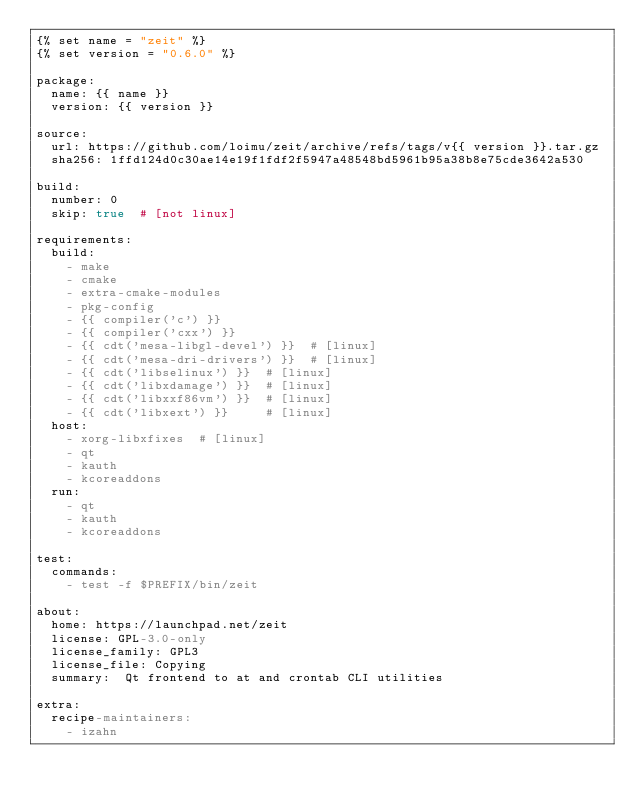<code> <loc_0><loc_0><loc_500><loc_500><_YAML_>{% set name = "zeit" %}
{% set version = "0.6.0" %}

package:
  name: {{ name }}
  version: {{ version }}

source:
  url: https://github.com/loimu/zeit/archive/refs/tags/v{{ version }}.tar.gz
  sha256: 1ffd124d0c30ae14e19f1fdf2f5947a48548bd5961b95a38b8e75cde3642a530

build:
  number: 0
  skip: true  # [not linux]

requirements:
  build:
    - make
    - cmake
    - extra-cmake-modules
    - pkg-config
    - {{ compiler('c') }}
    - {{ compiler('cxx') }}
    - {{ cdt('mesa-libgl-devel') }}  # [linux]
    - {{ cdt('mesa-dri-drivers') }}  # [linux]
    - {{ cdt('libselinux') }}  # [linux]
    - {{ cdt('libxdamage') }}  # [linux]
    - {{ cdt('libxxf86vm') }}  # [linux]
    - {{ cdt('libxext') }}     # [linux]
  host:
    - xorg-libxfixes  # [linux]
    - qt
    - kauth
    - kcoreaddons
  run:
    - qt
    - kauth
    - kcoreaddons

test:
  commands:
    - test -f $PREFIX/bin/zeit

about:
  home: https://launchpad.net/zeit
  license: GPL-3.0-only
  license_family: GPL3
  license_file: Copying
  summary:  Qt frontend to at and crontab CLI utilities 

extra:
  recipe-maintainers:
    - izahn
</code> 